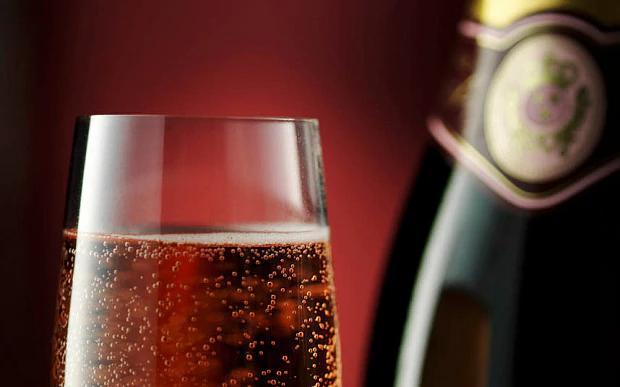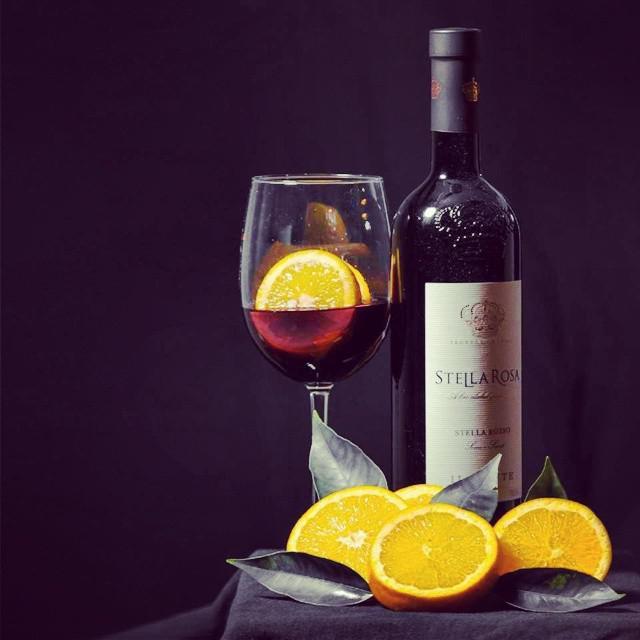The first image is the image on the left, the second image is the image on the right. For the images shown, is this caption "One image shows only part of one wine glass and part of one bottle of wine." true? Answer yes or no. Yes. The first image is the image on the left, the second image is the image on the right. Evaluate the accuracy of this statement regarding the images: "There are 2 bottles of wine standing upright.". Is it true? Answer yes or no. Yes. 